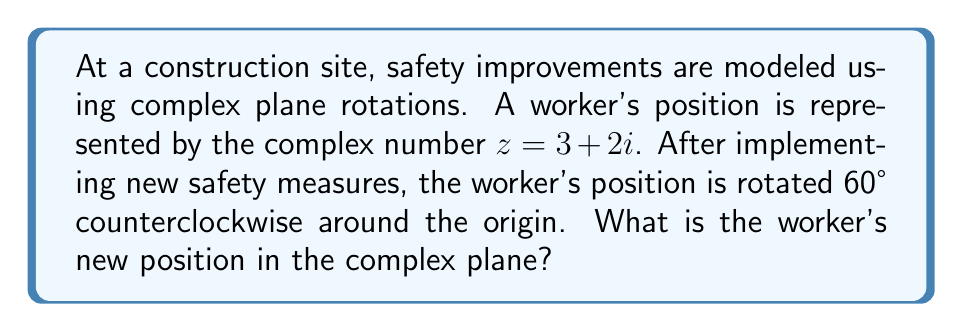Could you help me with this problem? To solve this problem, we'll follow these steps:

1) Recall that rotating a point in the complex plane by an angle $\theta$ counterclockwise is equivalent to multiplying the complex number by $e^{i\theta}$.

2) In this case, $\theta = 60°$. We need to convert this to radians:
   $60° = \frac{\pi}{3}$ radians

3) Now, we can express the rotation as:
   $z_{new} = z \cdot e^{i\frac{\pi}{3}}$

4) We know that $e^{i\frac{\pi}{3}} = \cos(\frac{\pi}{3}) + i\sin(\frac{\pi}{3})$
   $= \frac{1}{2} + i\frac{\sqrt{3}}{2}$

5) Let's multiply:
   $z_{new} = (3 + 2i) \cdot (\frac{1}{2} + i\frac{\sqrt{3}}{2})$
   $= (3 \cdot \frac{1}{2} - 2 \cdot \frac{\sqrt{3}}{2}) + i(3 \cdot \frac{\sqrt{3}}{2} + 2 \cdot \frac{1}{2})$
   $= (\frac{3}{2} - \sqrt{3}) + i(\frac{3\sqrt{3}}{2} + 1)$

6) Simplifying:
   $z_{new} = (\frac{3}{2} - \sqrt{3}) + i(\frac{3\sqrt{3}}{2} + 1)$

This represents the worker's new position in the complex plane after the safety rotation.
Answer: $(\frac{3}{2} - \sqrt{3}) + i(\frac{3\sqrt{3}}{2} + 1)$ 